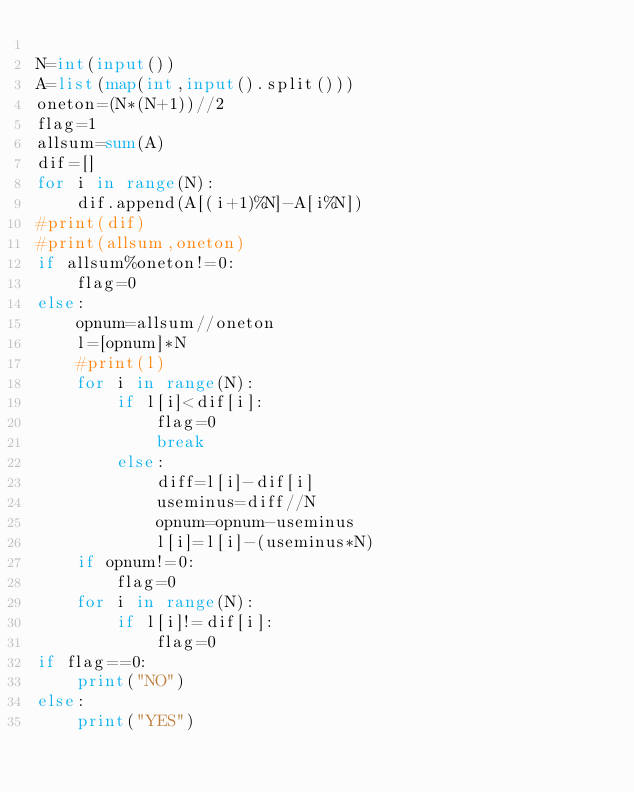Convert code to text. <code><loc_0><loc_0><loc_500><loc_500><_Python_>
N=int(input())
A=list(map(int,input().split()))
oneton=(N*(N+1))//2
flag=1
allsum=sum(A)
dif=[]
for i in range(N):
    dif.append(A[(i+1)%N]-A[i%N])
#print(dif)
#print(allsum,oneton)
if allsum%oneton!=0:
    flag=0
else:
    opnum=allsum//oneton        
    l=[opnum]*N                 
    #print(l)
    for i in range(N):
        if l[i]<dif[i]:         
            flag=0
            break
        else:                   
            diff=l[i]-dif[i]    
            useminus=diff//N    
            opnum=opnum-useminus
            l[i]=l[i]-(useminus*N)
    if opnum!=0:                    
        flag=0
    for i in range(N):              
        if l[i]!=dif[i]:
            flag=0
if flag==0:
    print("NO")
else:
    print("YES")


</code> 